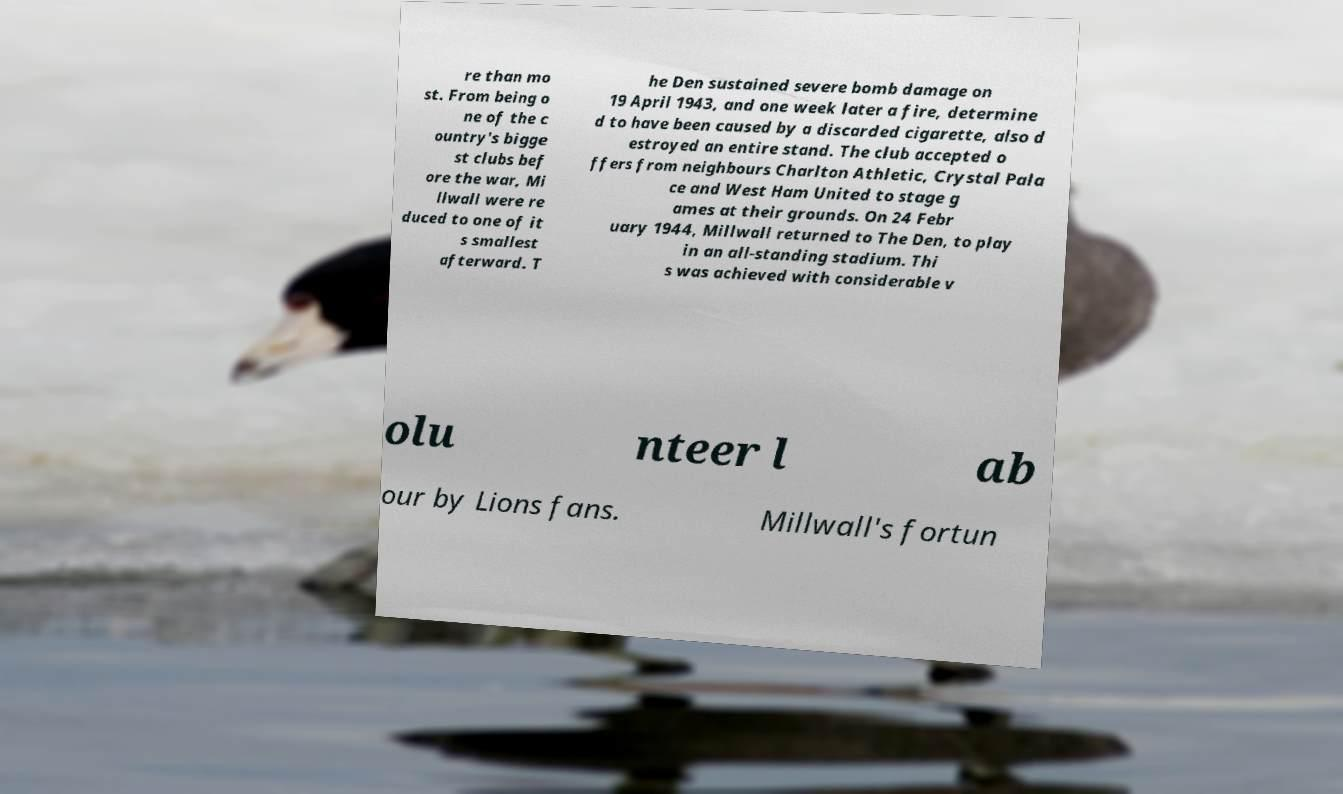What messages or text are displayed in this image? I need them in a readable, typed format. re than mo st. From being o ne of the c ountry's bigge st clubs bef ore the war, Mi llwall were re duced to one of it s smallest afterward. T he Den sustained severe bomb damage on 19 April 1943, and one week later a fire, determine d to have been caused by a discarded cigarette, also d estroyed an entire stand. The club accepted o ffers from neighbours Charlton Athletic, Crystal Pala ce and West Ham United to stage g ames at their grounds. On 24 Febr uary 1944, Millwall returned to The Den, to play in an all-standing stadium. Thi s was achieved with considerable v olu nteer l ab our by Lions fans. Millwall's fortun 